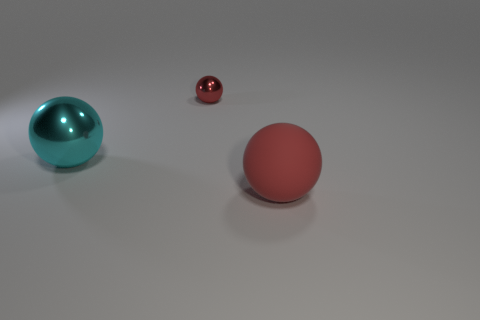Subtract all cyan balls. How many balls are left? 2 Subtract all cyan spheres. How many spheres are left? 2 Add 2 rubber spheres. How many objects exist? 5 Subtract all yellow cylinders. How many cyan balls are left? 1 Subtract all tiny metal balls. Subtract all tiny green things. How many objects are left? 2 Add 3 tiny red spheres. How many tiny red spheres are left? 4 Add 1 brown rubber things. How many brown rubber things exist? 1 Subtract 0 blue blocks. How many objects are left? 3 Subtract 1 spheres. How many spheres are left? 2 Subtract all brown balls. Subtract all purple cylinders. How many balls are left? 3 